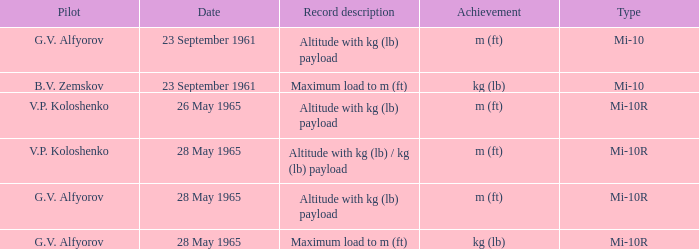Record description of maximum load to m (ft), and a Date of 23 september 1961 is what pilot? B.V. Zemskov. 